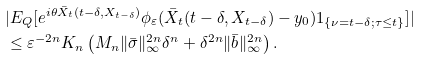<formula> <loc_0><loc_0><loc_500><loc_500>& | E _ { Q } [ e ^ { i \theta \bar { X } _ { t } ( t - \delta , X _ { t - \delta } ) } \phi _ { \varepsilon } ( \bar { X } _ { t } ( t - \delta , X _ { t - \delta } ) - y _ { 0 } ) 1 _ { \{ \nu = t - \delta ; \tau \leq t \} } ] | \\ & \leq \varepsilon ^ { - 2 n } K _ { n } \left ( M _ { n } \| \bar { \sigma } \| ^ { 2 n } _ { \infty } \delta ^ { n } + \delta ^ { 2 n } \| \bar { b } \| _ { \infty } ^ { 2 n } \right ) .</formula> 